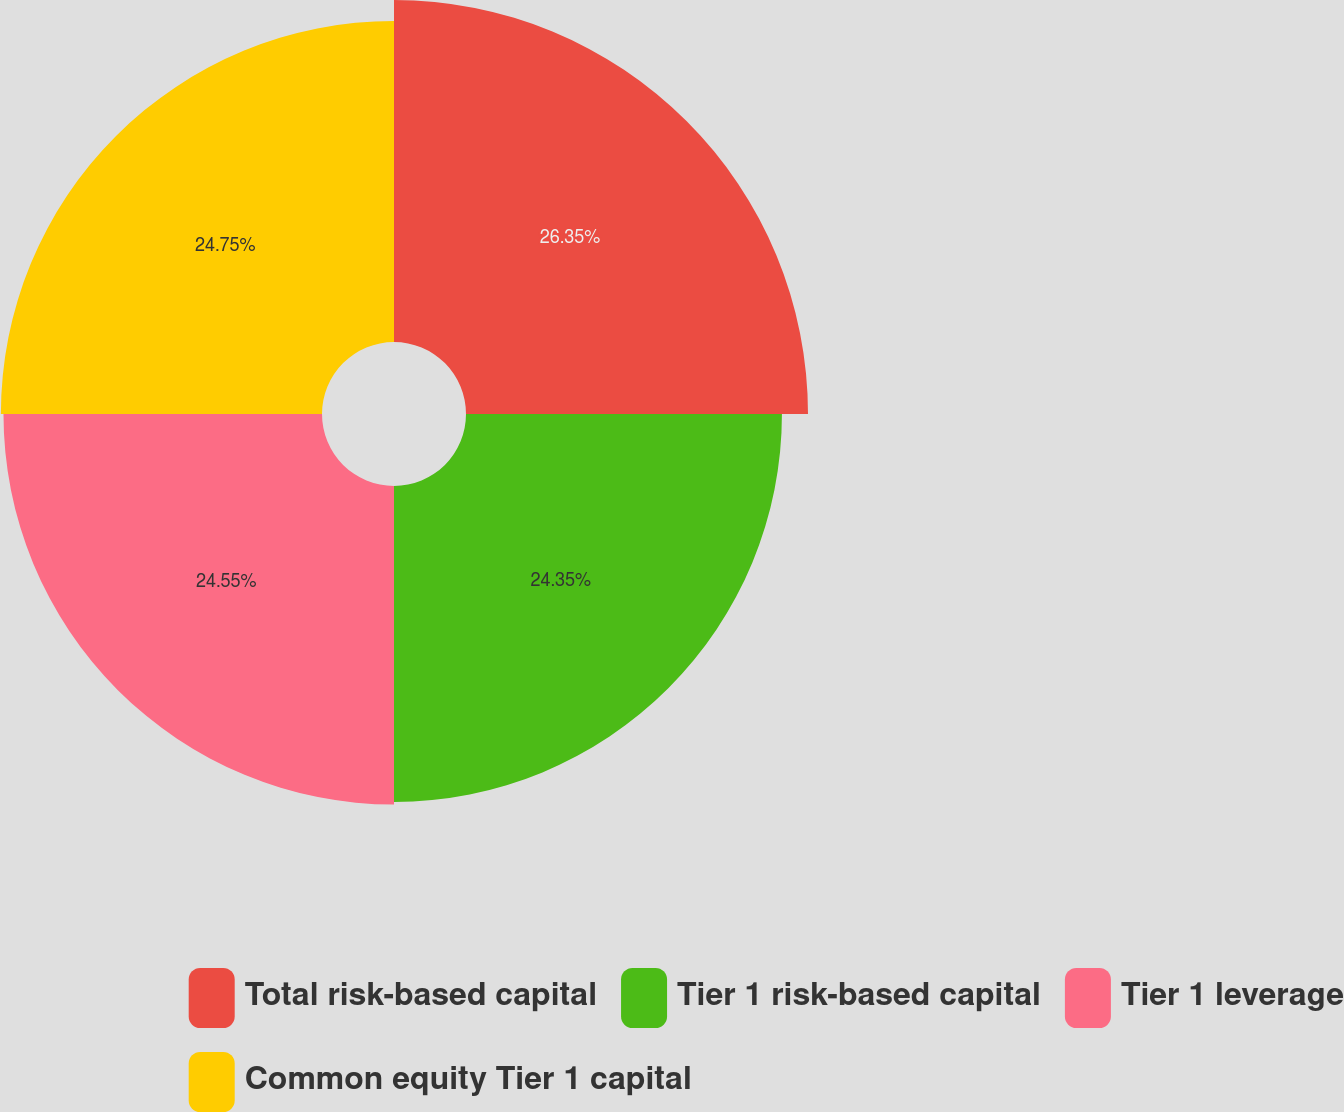<chart> <loc_0><loc_0><loc_500><loc_500><pie_chart><fcel>Total risk-based capital<fcel>Tier 1 risk-based capital<fcel>Tier 1 leverage<fcel>Common equity Tier 1 capital<nl><fcel>26.36%<fcel>24.35%<fcel>24.55%<fcel>24.75%<nl></chart> 